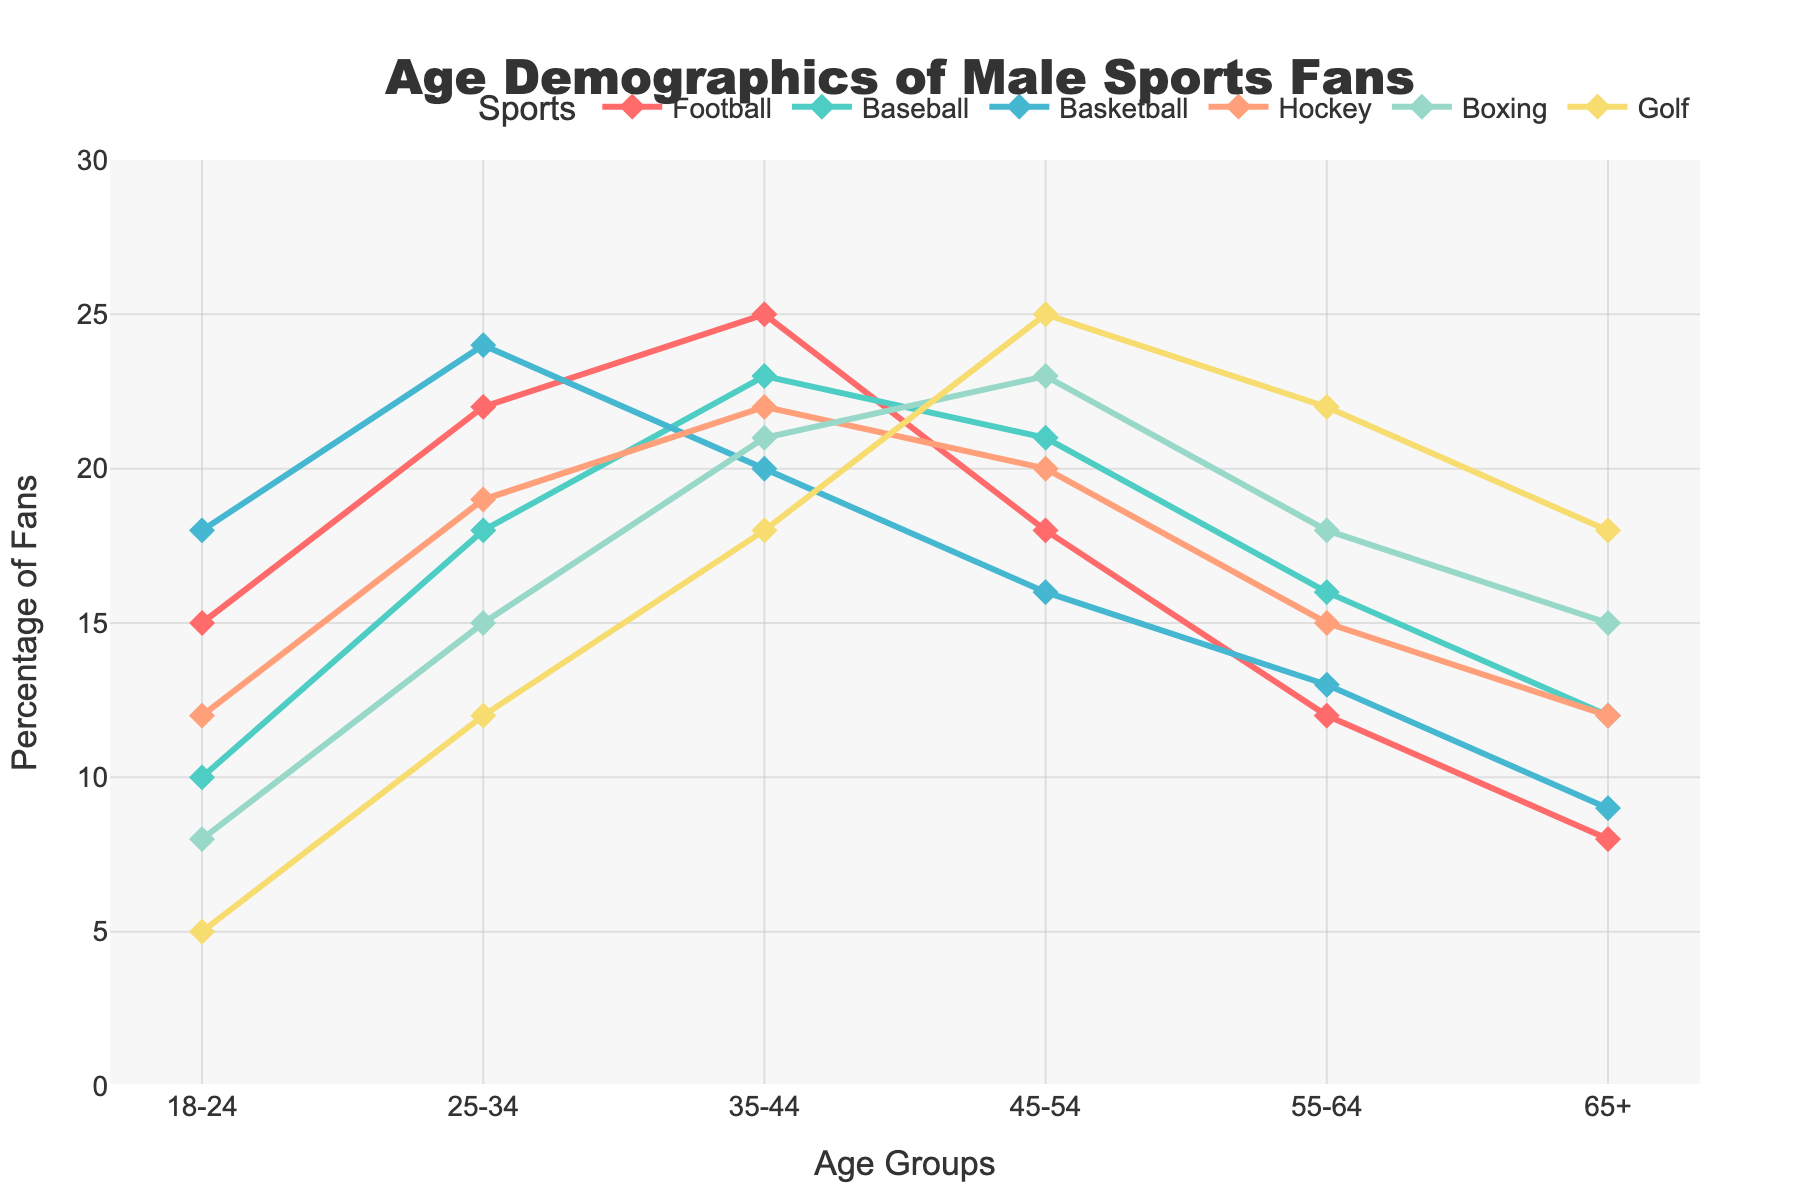What is the title of the chart? The title of the chart is typically displayed prominently at the top and often in a larger or bold font, making it easy to identify.
Answer: Age Demographics of Male Sports Fans Which sport has the highest percentage of fans in the 55-64 age group? Locate the 55-64 age group on the x-axis, then see which sport has the highest point on the y-axis for that age group.
Answer: Golf What is the percentage of Football fans in the 18-24 age group? Find the 18-24 age group on the x-axis and follow up vertically to where the Football line intersects.
Answer: 15% Which age group has the smallest percentage of fans for Basketball? Identify the points of the Basketball line across all age groups. The smallest value among them represents the least percentage.
Answer: 65+ By how much does the percentage of Baseball fans in the 35-44 age group exceed the percentage in the 25-34 age group? Subtract the percentage of Baseball fans in the 25-34 age group from that in the 35-44 age group: 23 - 18 = 5
Answer: 5% What is the total percentage of Boxing fans for the 18-24 and 25-34 age groups combined? Add the percentages for Boxing in both age groups: 8 + 15 = 23
Answer: 23% Which sport shows the steepest decline in percentage from the 35-44 age group to the 45-54 age group? Determine the differences in percentages between the 35-44 and 45-54 age groups for each sport and identify the largest one.
Answer: Football (difference of 7) What is the most common age group among Basketball fans? Look for the age group where the Basketball line reaches its highest point on the y-axis.
Answer: 25-34 Compare the percentage distribution for Hockey fans in the 35-44 and 45-54 age groups. Which is greater and by how much? Identify the percentages for Hockey in both age groups and subtract the smaller from the larger: 22 - 20 = 2
Answer: 35-44 by 2% Which sport has the most evenly distributed fan base across all age groups? Observe each sport's line for uniformity across age groups, with minimal peaks and valleys indicating even distribution.
Answer: Baseball 